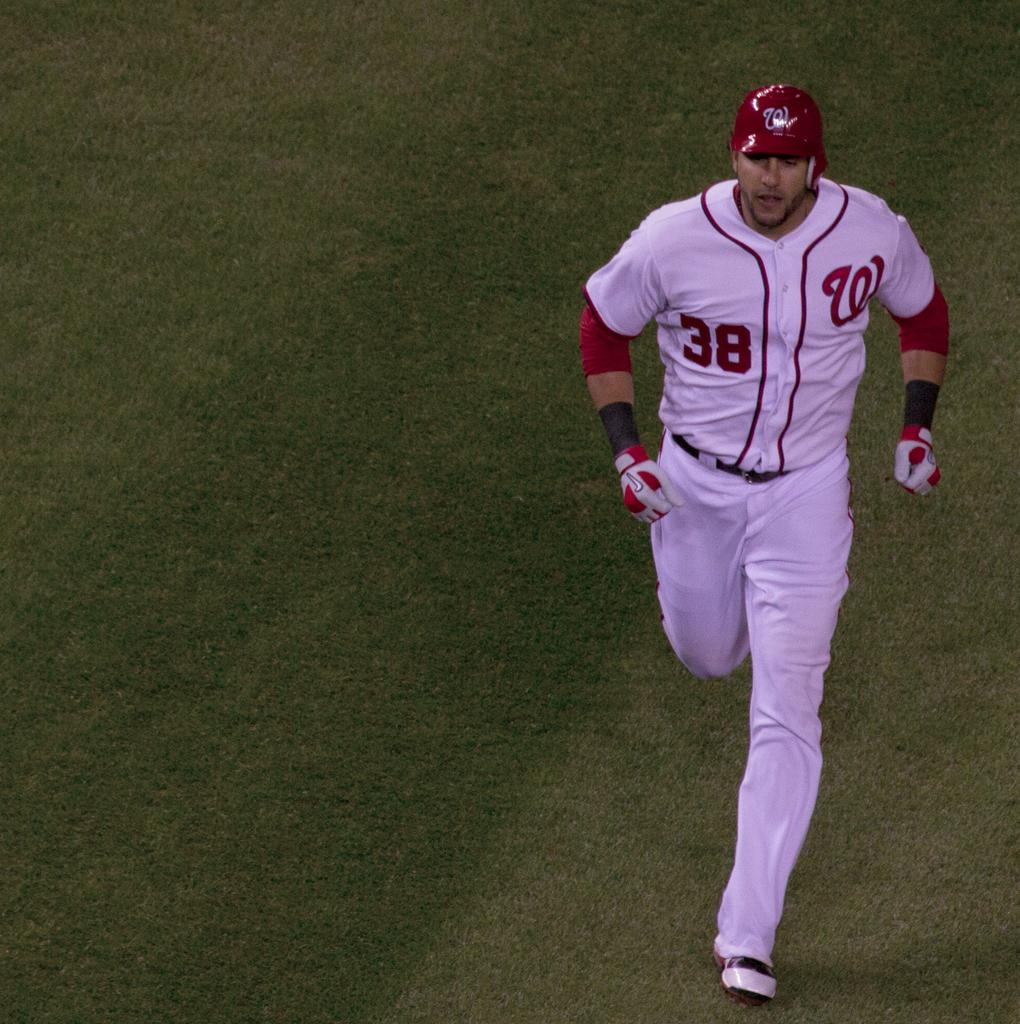Provide a one-sentence caption for the provided image. A washington nationals player with the number 38 on HIS JERSEY. 